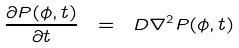<formula> <loc_0><loc_0><loc_500><loc_500>\frac { \partial P ( \phi , t ) } { \partial t } \ = \ D \nabla ^ { 2 } P ( \phi , t )</formula> 